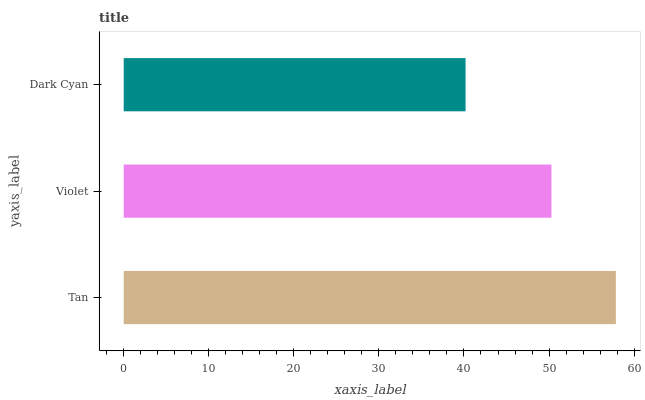Is Dark Cyan the minimum?
Answer yes or no. Yes. Is Tan the maximum?
Answer yes or no. Yes. Is Violet the minimum?
Answer yes or no. No. Is Violet the maximum?
Answer yes or no. No. Is Tan greater than Violet?
Answer yes or no. Yes. Is Violet less than Tan?
Answer yes or no. Yes. Is Violet greater than Tan?
Answer yes or no. No. Is Tan less than Violet?
Answer yes or no. No. Is Violet the high median?
Answer yes or no. Yes. Is Violet the low median?
Answer yes or no. Yes. Is Tan the high median?
Answer yes or no. No. Is Tan the low median?
Answer yes or no. No. 